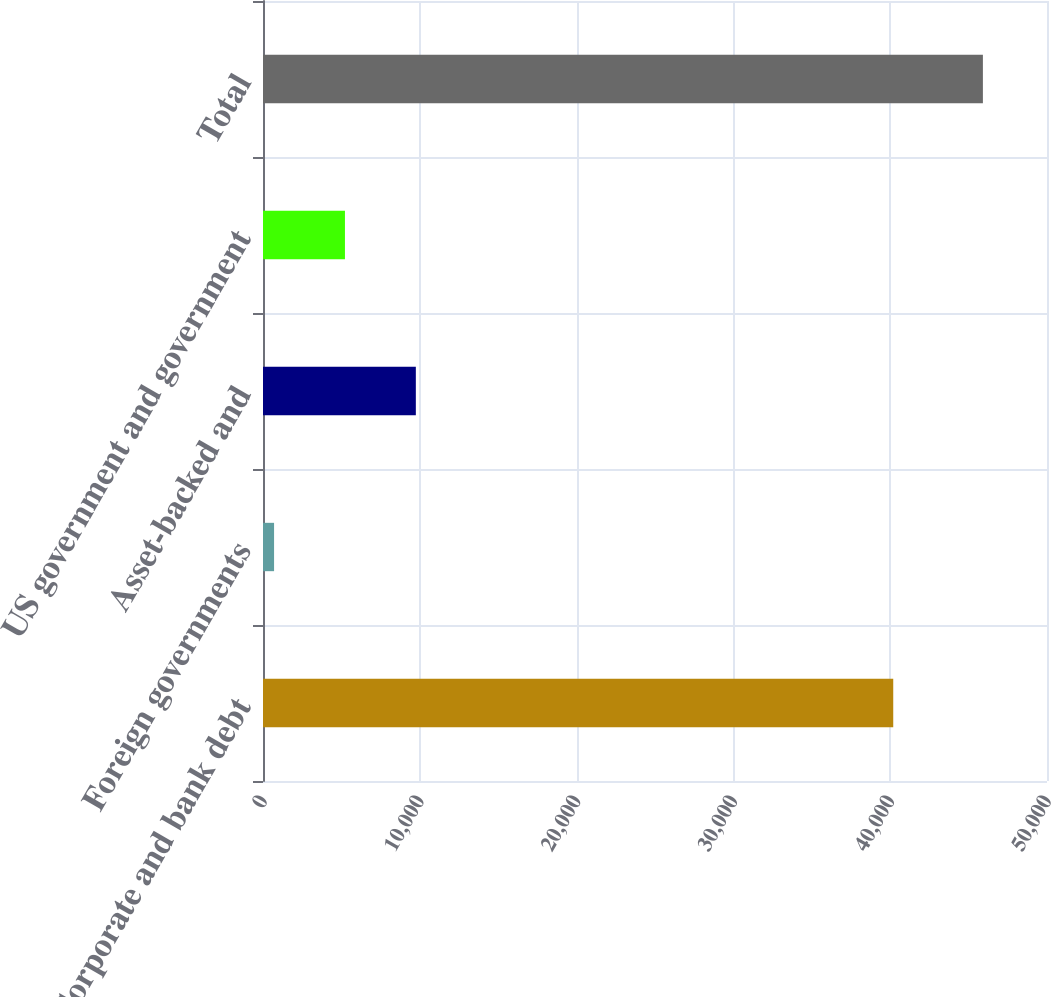Convert chart. <chart><loc_0><loc_0><loc_500><loc_500><bar_chart><fcel>Corporate and bank debt<fcel>Foreign governments<fcel>Asset-backed and<fcel>US government and government<fcel>Total<nl><fcel>40194<fcel>706<fcel>9747.2<fcel>5226.6<fcel>45912<nl></chart> 